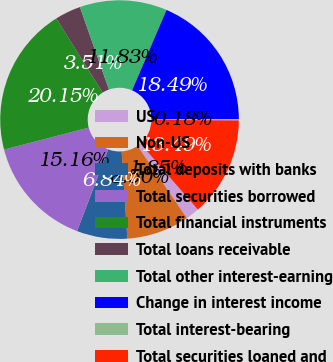Convert chart. <chart><loc_0><loc_0><loc_500><loc_500><pie_chart><fcel>US<fcel>Non-US<fcel>Total deposits with banks<fcel>Total securities borrowed<fcel>Total financial instruments<fcel>Total loans receivable<fcel>Total other interest-earning<fcel>Change in interest income<fcel>Total interest-bearing<fcel>Total securities loaned and<nl><fcel>1.85%<fcel>8.5%<fcel>6.84%<fcel>15.16%<fcel>20.15%<fcel>3.51%<fcel>11.83%<fcel>18.49%<fcel>0.18%<fcel>13.49%<nl></chart> 